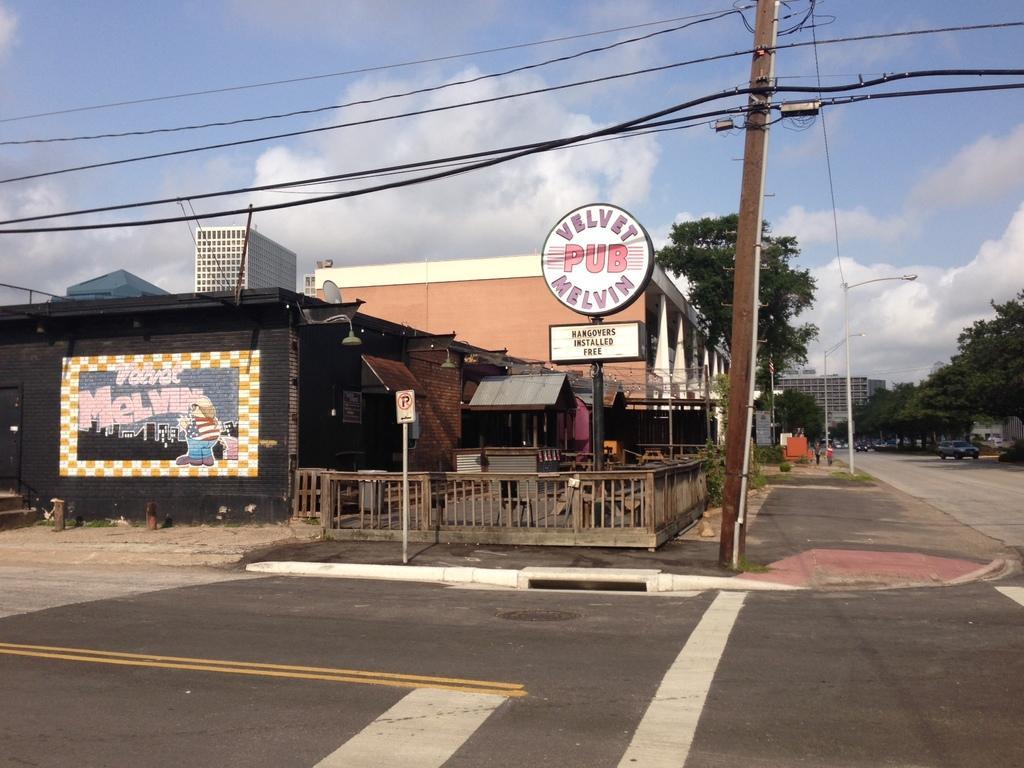Could you give a brief overview of what you see in this image? This image is clicked on the road. In the front, we can see the buildings. It looks like a pub. In the middle, there is a pole along with wires. At the top, there are clouds in the sky. On the right, there are trees. 